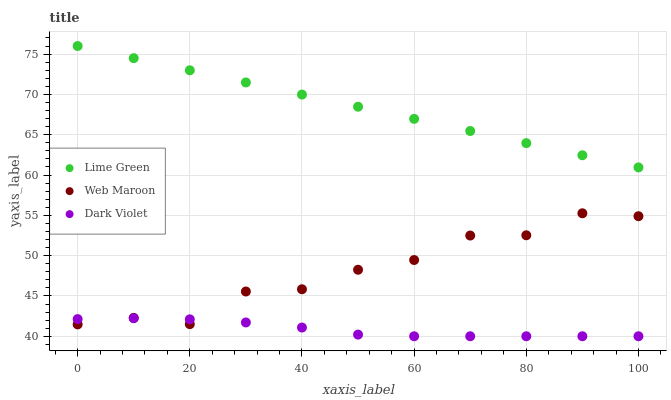Does Dark Violet have the minimum area under the curve?
Answer yes or no. Yes. Does Lime Green have the maximum area under the curve?
Answer yes or no. Yes. Does Lime Green have the minimum area under the curve?
Answer yes or no. No. Does Dark Violet have the maximum area under the curve?
Answer yes or no. No. Is Lime Green the smoothest?
Answer yes or no. Yes. Is Web Maroon the roughest?
Answer yes or no. Yes. Is Dark Violet the smoothest?
Answer yes or no. No. Is Dark Violet the roughest?
Answer yes or no. No. Does Dark Violet have the lowest value?
Answer yes or no. Yes. Does Lime Green have the lowest value?
Answer yes or no. No. Does Lime Green have the highest value?
Answer yes or no. Yes. Does Dark Violet have the highest value?
Answer yes or no. No. Is Dark Violet less than Lime Green?
Answer yes or no. Yes. Is Lime Green greater than Dark Violet?
Answer yes or no. Yes. Does Dark Violet intersect Web Maroon?
Answer yes or no. Yes. Is Dark Violet less than Web Maroon?
Answer yes or no. No. Is Dark Violet greater than Web Maroon?
Answer yes or no. No. Does Dark Violet intersect Lime Green?
Answer yes or no. No. 